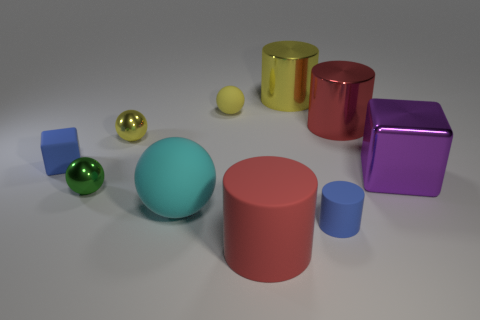Subtract all balls. How many objects are left? 6 Add 3 blue rubber things. How many blue rubber things exist? 5 Subtract 0 gray cylinders. How many objects are left? 10 Subtract all big yellow shiny objects. Subtract all cubes. How many objects are left? 7 Add 8 tiny blocks. How many tiny blocks are left? 9 